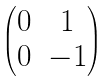Convert formula to latex. <formula><loc_0><loc_0><loc_500><loc_500>\begin{pmatrix} 0 & 1 \\ 0 & - 1 \end{pmatrix}</formula> 